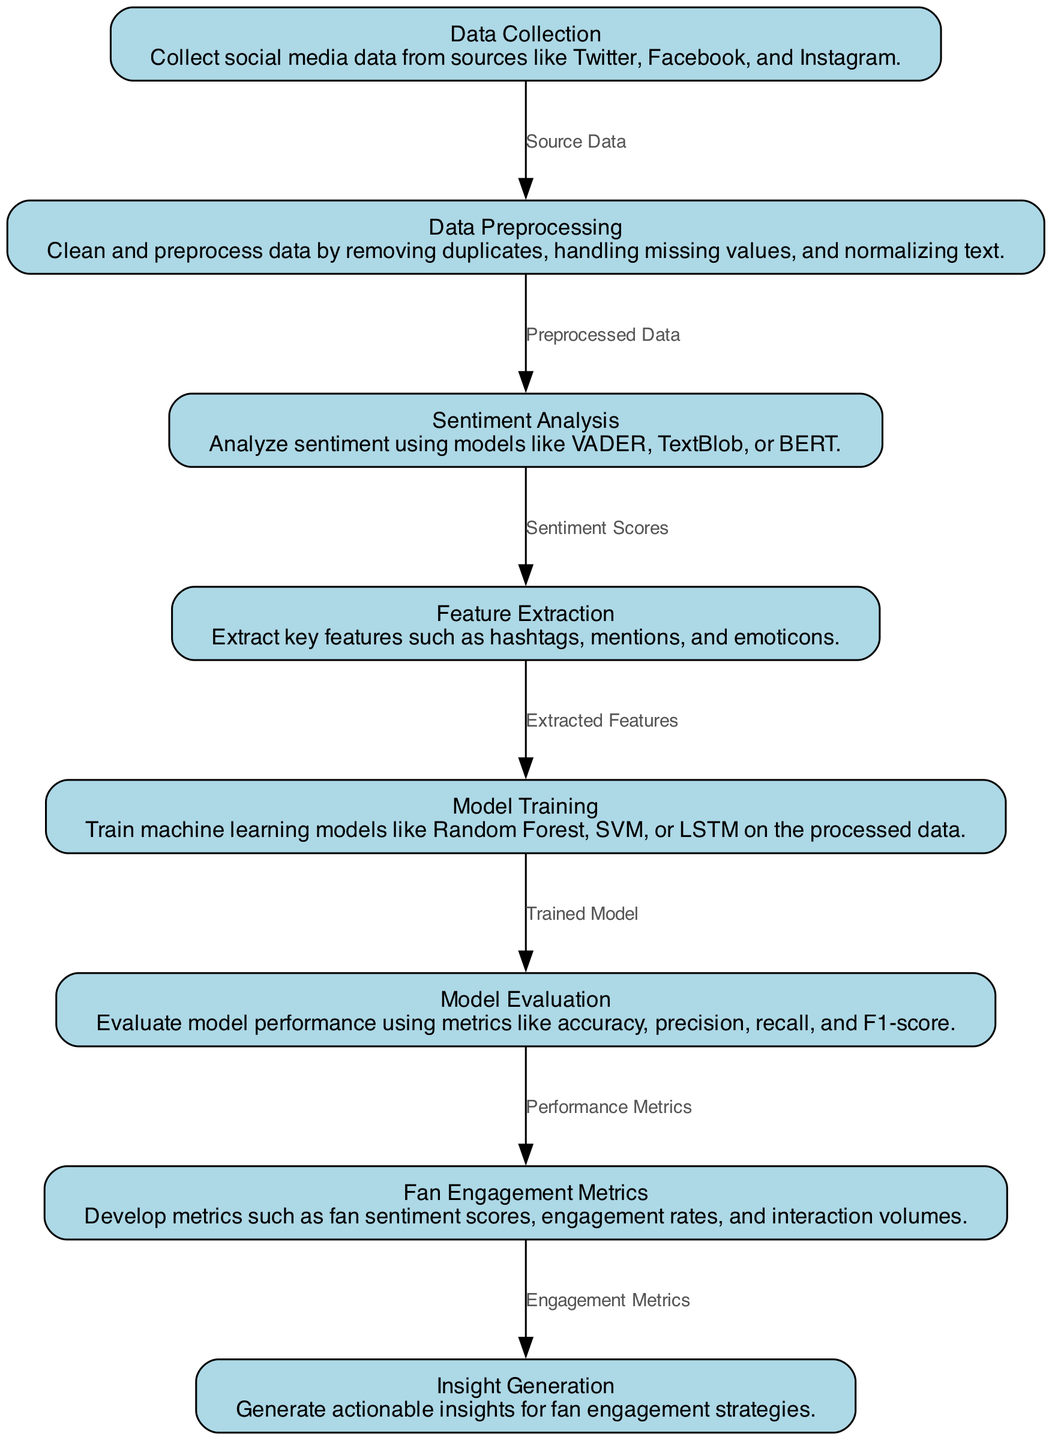What is the first step in the diagram? The first step is Data Collection, which indicates that the diagram starts with the collection of social media data from various sources.
Answer: Data Collection How many nodes are in the diagram? By counting the nodes listed in the diagram, we find there are eight distinct nodes present.
Answer: Eight What is the output of Data Preprocessing? The output of Data Preprocessing is labeled as Preprocessed Data, which connects to the next step in the diagram, Sentiment Analysis.
Answer: Preprocessed Data Which models are mentioned for Model Training? The models mentioned for Model Training are Random Forest, SVM, and LSTM as shown in the description of the respective node.
Answer: Random Forest, SVM, LSTM What connects Sentiment Analysis to Feature Extraction? Sentiment Scores connect Sentiment Analysis to Feature Extraction, indicating that the scores generated are the input for the next step.
Answer: Sentiment Scores What metrics are used for Model Evaluation? The metrics used for Model Evaluation include accuracy, precision, recall, and F1-score, which are specifically listed under the description of that node.
Answer: Accuracy, precision, recall, F1-score How does fan engagement relate to insight generation? Fan Engagement Metrics serve as an input for Insight Generation, indicating that metrics developed in the prior step are utilized for generating insights.
Answer: Engagement Metrics What follows after Model Evaluation? After Model Evaluation, the next step is Fan Engagement Metrics, demonstrating the progression of the workflow after evaluating the model's performance.
Answer: Fan Engagement Metrics 